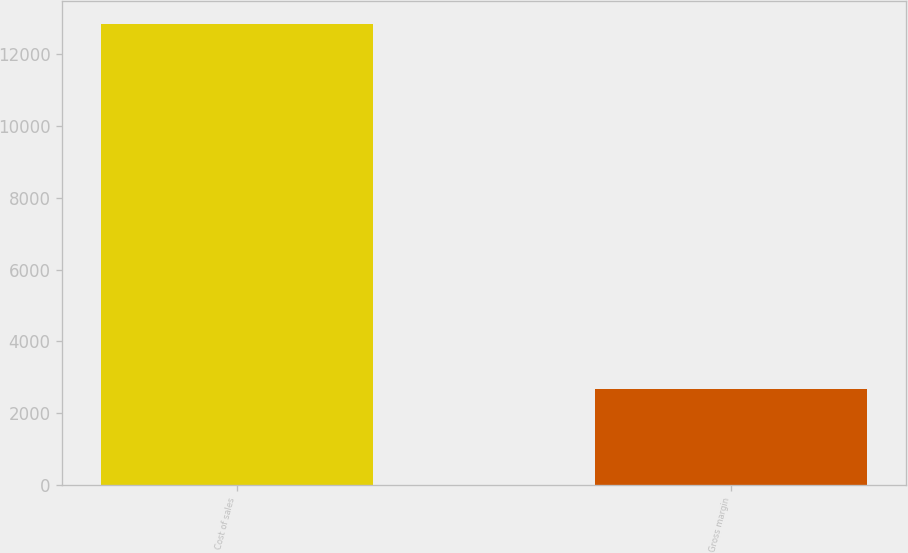Convert chart. <chart><loc_0><loc_0><loc_500><loc_500><bar_chart><fcel>Cost of sales<fcel>Gross margin<nl><fcel>12861<fcel>2658<nl></chart> 